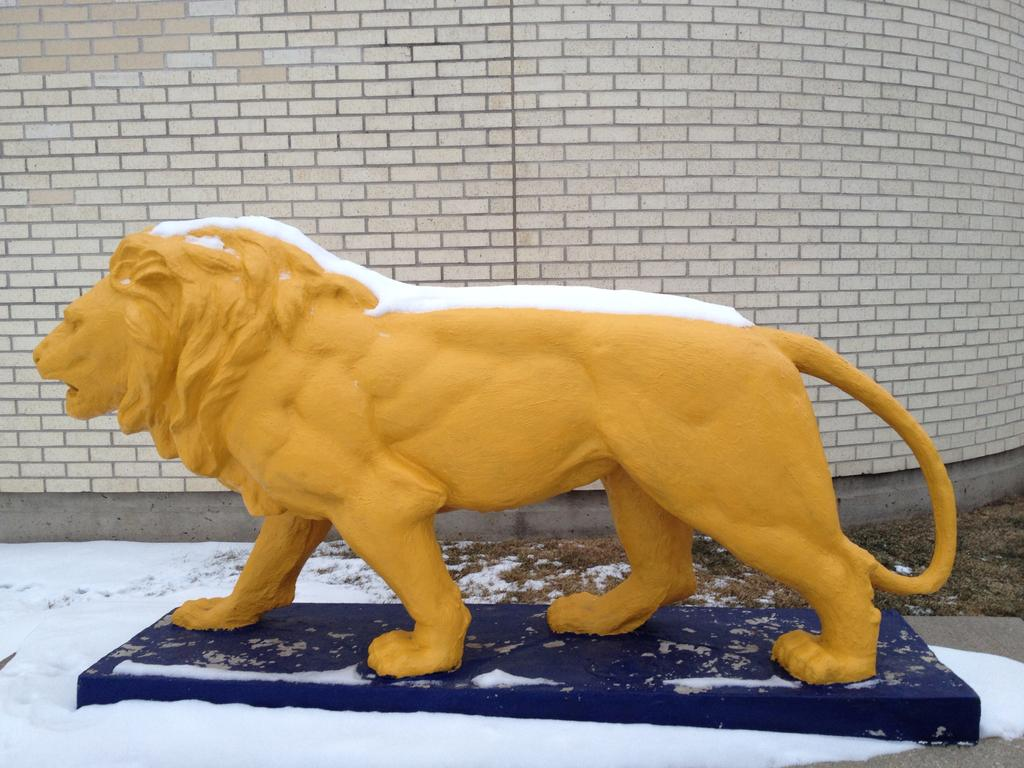What is the main subject of the image? There is a yellow lion statue in the image. What is the ground made of in the image? Snow is visible on the bottom of the image. What can be seen in the background of the image? There is a brick wall in the background of the image. What type of vegetation is on the right side of the image? Grass is present on the right side of the image. What type of ship can be seen sailing in the background of the image? There is no ship visible in the image; it features a yellow lion statue, snow, a brick wall, and grass. Is there a prison visible in the image? There is no prison present in the image. 